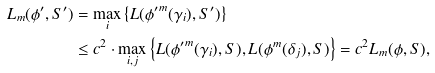Convert formula to latex. <formula><loc_0><loc_0><loc_500><loc_500>L _ { m } ( \phi ^ { \prime } , S ^ { \prime } ) & = \max _ { i } \left \{ L ( { \phi ^ { \prime } } ^ { m } ( \gamma _ { i } ) , S ^ { \prime } ) \right \} \\ & \leq c ^ { 2 } \cdot \max _ { i , j } \left \{ L ( { \phi ^ { \prime } } ^ { m } ( \gamma _ { i } ) , { S } ) , L ( \phi ^ { m } ( \delta _ { j } ) , S ) \right \} = c ^ { 2 } L _ { m } ( \phi , S ) ,</formula> 